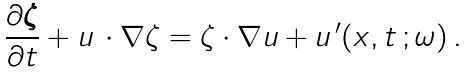<formula> <loc_0><loc_0><loc_500><loc_500>\frac { \partial \boldsymbol \zeta } { \partial t } + { u } \, \cdot \nabla \zeta = \zeta \cdot \nabla { u } + { u } ^ { \, \prime } ( { x } , t \, ; \omega ) \, .</formula> 